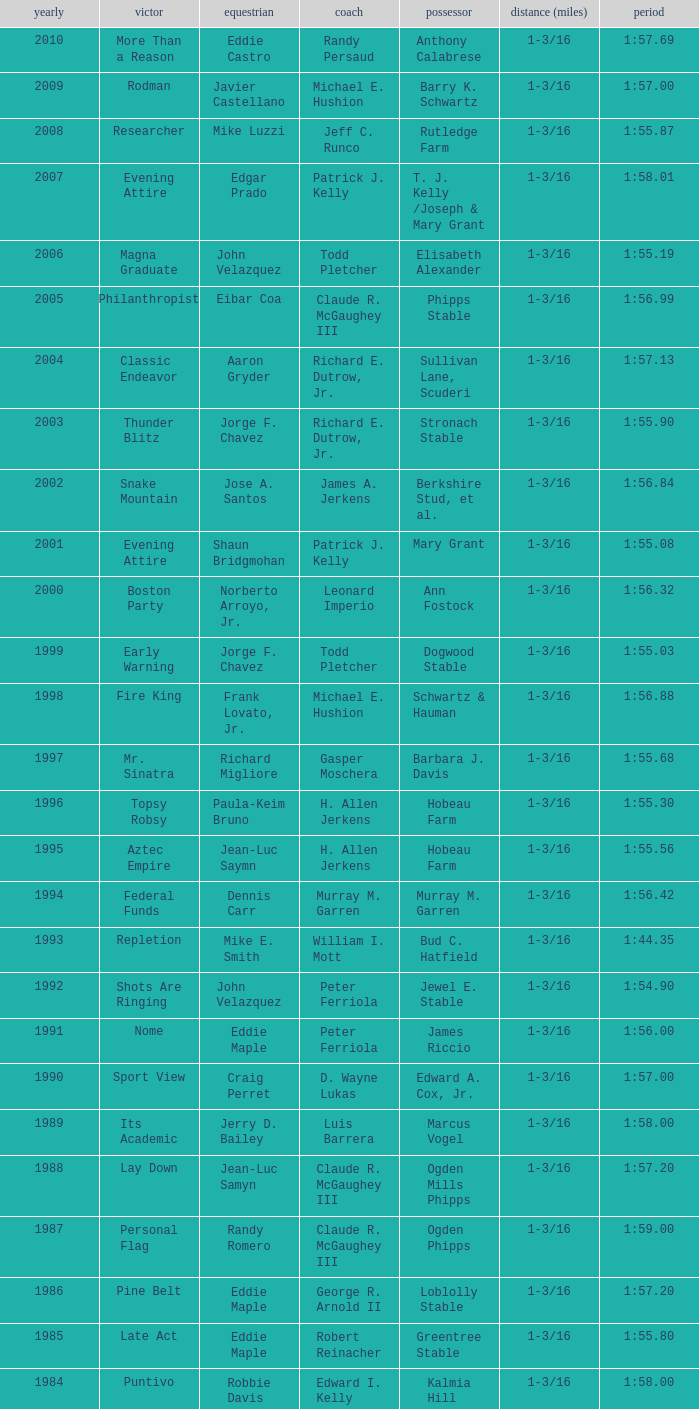When the winner was No Race in a year after 1909, what was the distance? 1 mile, 1 mile, 1 mile. 